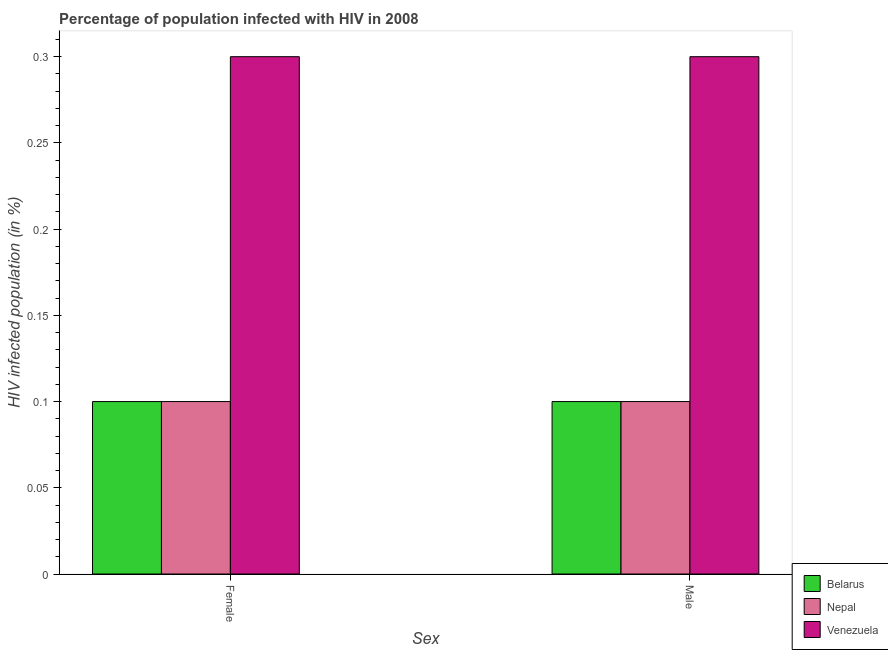How many groups of bars are there?
Provide a short and direct response. 2. Are the number of bars on each tick of the X-axis equal?
Give a very brief answer. Yes. How many bars are there on the 2nd tick from the left?
Keep it short and to the point. 3. What is the label of the 2nd group of bars from the left?
Your response must be concise. Male. Across all countries, what is the maximum percentage of females who are infected with hiv?
Give a very brief answer. 0.3. Across all countries, what is the minimum percentage of females who are infected with hiv?
Provide a short and direct response. 0.1. In which country was the percentage of females who are infected with hiv maximum?
Your answer should be compact. Venezuela. In which country was the percentage of males who are infected with hiv minimum?
Give a very brief answer. Belarus. What is the total percentage of females who are infected with hiv in the graph?
Your response must be concise. 0.5. What is the difference between the percentage of females who are infected with hiv in Venezuela and that in Belarus?
Ensure brevity in your answer.  0.2. What is the average percentage of females who are infected with hiv per country?
Offer a terse response. 0.17. What is the difference between the percentage of males who are infected with hiv and percentage of females who are infected with hiv in Venezuela?
Keep it short and to the point. 0. What does the 1st bar from the left in Male represents?
Ensure brevity in your answer.  Belarus. What does the 2nd bar from the right in Female represents?
Provide a succinct answer. Nepal. How many countries are there in the graph?
Your response must be concise. 3. What is the difference between two consecutive major ticks on the Y-axis?
Your answer should be very brief. 0.05. Does the graph contain any zero values?
Offer a terse response. No. Does the graph contain grids?
Your answer should be compact. No. Where does the legend appear in the graph?
Ensure brevity in your answer.  Bottom right. How are the legend labels stacked?
Your answer should be compact. Vertical. What is the title of the graph?
Provide a succinct answer. Percentage of population infected with HIV in 2008. Does "Bahrain" appear as one of the legend labels in the graph?
Make the answer very short. No. What is the label or title of the X-axis?
Your answer should be very brief. Sex. What is the label or title of the Y-axis?
Offer a very short reply. HIV infected population (in %). What is the HIV infected population (in %) in Nepal in Female?
Offer a very short reply. 0.1. What is the HIV infected population (in %) of Venezuela in Female?
Your answer should be compact. 0.3. What is the HIV infected population (in %) in Belarus in Male?
Provide a succinct answer. 0.1. What is the HIV infected population (in %) in Nepal in Male?
Your answer should be compact. 0.1. What is the HIV infected population (in %) in Venezuela in Male?
Offer a very short reply. 0.3. Across all Sex, what is the maximum HIV infected population (in %) in Nepal?
Ensure brevity in your answer.  0.1. Across all Sex, what is the minimum HIV infected population (in %) of Venezuela?
Keep it short and to the point. 0.3. What is the total HIV infected population (in %) in Nepal in the graph?
Your answer should be compact. 0.2. What is the total HIV infected population (in %) of Venezuela in the graph?
Make the answer very short. 0.6. What is the difference between the HIV infected population (in %) in Nepal in Female and that in Male?
Provide a succinct answer. 0. What is the difference between the HIV infected population (in %) of Venezuela in Female and that in Male?
Your answer should be very brief. 0. What is the difference between the HIV infected population (in %) in Belarus in Female and the HIV infected population (in %) in Nepal in Male?
Give a very brief answer. 0. What is the difference between the HIV infected population (in %) of Belarus in Female and the HIV infected population (in %) of Venezuela in Male?
Your response must be concise. -0.2. What is the difference between the HIV infected population (in %) of Nepal in Female and the HIV infected population (in %) of Venezuela in Male?
Ensure brevity in your answer.  -0.2. What is the difference between the HIV infected population (in %) of Belarus and HIV infected population (in %) of Nepal in Female?
Provide a short and direct response. 0. What is the difference between the HIV infected population (in %) in Belarus and HIV infected population (in %) in Venezuela in Female?
Ensure brevity in your answer.  -0.2. What is the difference between the HIV infected population (in %) in Belarus and HIV infected population (in %) in Nepal in Male?
Offer a terse response. 0. What is the difference between the HIV infected population (in %) of Belarus and HIV infected population (in %) of Venezuela in Male?
Your answer should be very brief. -0.2. What is the ratio of the HIV infected population (in %) of Belarus in Female to that in Male?
Your answer should be compact. 1. What is the ratio of the HIV infected population (in %) of Nepal in Female to that in Male?
Provide a short and direct response. 1. What is the difference between the highest and the second highest HIV infected population (in %) in Belarus?
Your answer should be compact. 0. What is the difference between the highest and the second highest HIV infected population (in %) in Venezuela?
Ensure brevity in your answer.  0. What is the difference between the highest and the lowest HIV infected population (in %) in Belarus?
Offer a terse response. 0. What is the difference between the highest and the lowest HIV infected population (in %) of Venezuela?
Give a very brief answer. 0. 